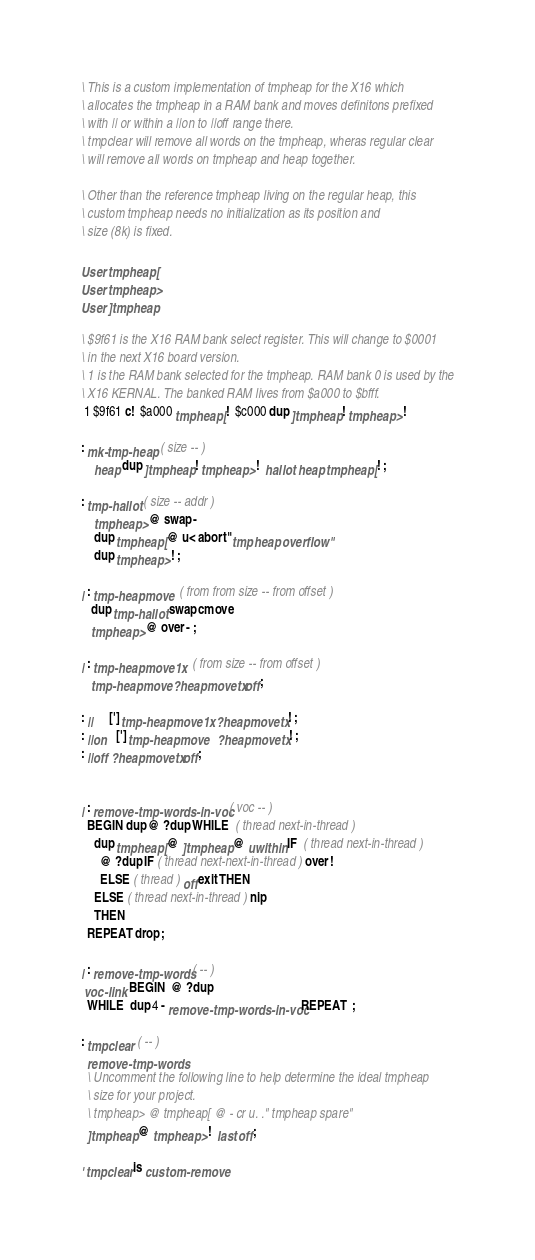Convert code to text. <code><loc_0><loc_0><loc_500><loc_500><_Forth_>
\ This is a custom implementation of tmpheap for the X16 which
\ allocates the tmpheap in a RAM bank and moves definitons prefixed
\ with || or within a ||on to ||off range there.
\ tmpclear will remove all words on the tmpheap, wheras regular clear
\ will remove all words on tmpheap and heap together.

\ Other than the reference tmpheap living on the regular heap, this
\ custom tmpheap needs no initialization as its position and
\ size (8k) is fixed.

User tmpheap[
User tmpheap>
User ]tmpheap

\ $9f61 is the X16 RAM bank select register. This will change to $0001
\ in the next X16 board version.
\ 1 is the RAM bank selected for the tmpheap. RAM bank 0 is used by the
\ X16 KERNAL. The banked RAM lives from $a000 to $bfff.
 1 $9f61 c!  $a000 tmpheap[ !  $c000 dup ]tmpheap ! tmpheap> !

: mk-tmp-heap  ( size -- )
    heap dup ]tmpheap ! tmpheap> !  hallot  heap tmpheap[ ! ;

: tmp-hallot  ( size -- addr )
    tmpheap> @ swap -
    dup tmpheap[ @ u< abort" tmp heap overflow"
    dup tmpheap> ! ;

| : tmp-heapmove   ( from from size -- from offset )
   dup tmp-hallot  swap cmove
   tmpheap> @ over - ;

| : tmp-heapmove1x   ( from size -- from offset )
   tmp-heapmove  ?heapmovetx off ;

: ||     ['] tmp-heapmove1x  ?heapmovetx ! ;
: ||on   ['] tmp-heapmove    ?heapmovetx ! ;
: ||off  ?heapmovetx off ;


| : remove-tmp-words-in-voc  ( voc -- )
  BEGIN dup @ ?dup WHILE  ( thread next-in-thread )
    dup tmpheap[ @ ]tmpheap @ uwithin IF  ( thread next-in-thread )
      @ ?dup IF ( thread next-next-in-thread ) over !
      ELSE ( thread ) off exit THEN
    ELSE ( thread next-in-thread ) nip
    THEN
  REPEAT drop ;

| : remove-tmp-words ( -- )
 voc-link  BEGIN  @ ?dup
  WHILE  dup 4 - remove-tmp-words-in-voc REPEAT  ;

: tmpclear  ( -- )
  remove-tmp-words
  \ Uncomment the following line to help determine the ideal tmpheap
  \ size for your project.
  \ tmpheap> @ tmpheap[ @ - cr u. ." tmpheap spare"
  ]tmpheap @ tmpheap> !  last off ;

' tmpclear is custom-remove
</code> 